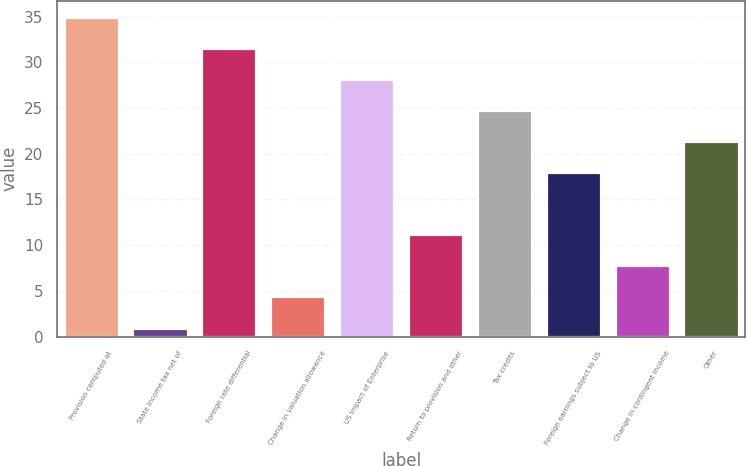Convert chart. <chart><loc_0><loc_0><loc_500><loc_500><bar_chart><fcel>Provision computed at<fcel>State income tax net of<fcel>Foreign rate differential<fcel>Change in valuation allowance<fcel>US impact of Enterprise<fcel>Return to provision and other<fcel>Tax credits<fcel>Foreign earnings subject to US<fcel>Change in contingent income<fcel>Other<nl><fcel>35<fcel>1<fcel>31.6<fcel>4.4<fcel>28.2<fcel>11.2<fcel>24.8<fcel>18<fcel>7.8<fcel>21.4<nl></chart> 